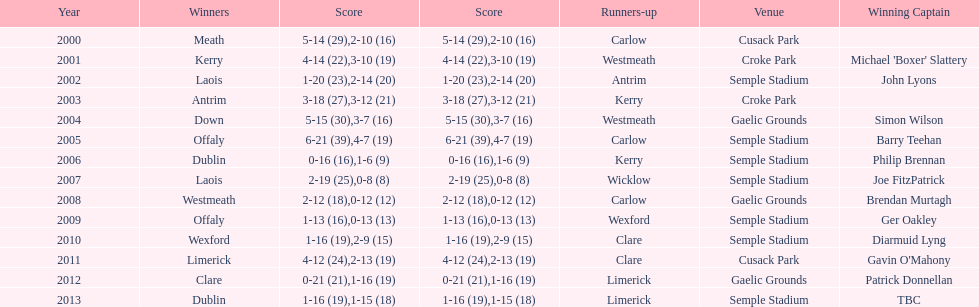Parse the table in full. {'header': ['Year', 'Winners', 'Score', 'Score', 'Runners-up', 'Venue', 'Winning Captain'], 'rows': [['2000', 'Meath', '5-14 (29)', '2-10 (16)', 'Carlow', 'Cusack Park', ''], ['2001', 'Kerry', '4-14 (22)', '3-10 (19)', 'Westmeath', 'Croke Park', "Michael 'Boxer' Slattery"], ['2002', 'Laois', '1-20 (23)', '2-14 (20)', 'Antrim', 'Semple Stadium', 'John Lyons'], ['2003', 'Antrim', '3-18 (27)', '3-12 (21)', 'Kerry', 'Croke Park', ''], ['2004', 'Down', '5-15 (30)', '3-7 (16)', 'Westmeath', 'Gaelic Grounds', 'Simon Wilson'], ['2005', 'Offaly', '6-21 (39)', '4-7 (19)', 'Carlow', 'Semple Stadium', 'Barry Teehan'], ['2006', 'Dublin', '0-16 (16)', '1-6 (9)', 'Kerry', 'Semple Stadium', 'Philip Brennan'], ['2007', 'Laois', '2-19 (25)', '0-8 (8)', 'Wicklow', 'Semple Stadium', 'Joe FitzPatrick'], ['2008', 'Westmeath', '2-12 (18)', '0-12 (12)', 'Carlow', 'Gaelic Grounds', 'Brendan Murtagh'], ['2009', 'Offaly', '1-13 (16)', '0-13 (13)', 'Wexford', 'Semple Stadium', 'Ger Oakley'], ['2010', 'Wexford', '1-16 (19)', '2-9 (15)', 'Clare', 'Semple Stadium', 'Diarmuid Lyng'], ['2011', 'Limerick', '4-12 (24)', '2-13 (19)', 'Clare', 'Cusack Park', "Gavin O'Mahony"], ['2012', 'Clare', '0-21 (21)', '1-16 (19)', 'Limerick', 'Gaelic Grounds', 'Patrick Donnellan'], ['2013', 'Dublin', '1-16 (19)', '1-15 (18)', 'Limerick', 'Semple Stadium', 'TBC']]} Who was the winning captain the last time the competition was held at the gaelic grounds venue? Patrick Donnellan. 